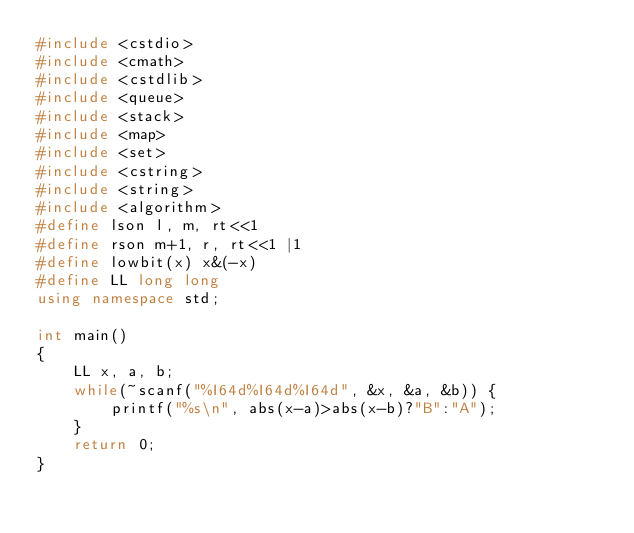<code> <loc_0><loc_0><loc_500><loc_500><_C++_>#include <cstdio>
#include <cmath>
#include <cstdlib>
#include <queue>
#include <stack>
#include <map>
#include <set>
#include <cstring>
#include <string>
#include <algorithm>
#define lson l, m, rt<<1
#define rson m+1, r, rt<<1 |1
#define lowbit(x) x&(-x)
#define LL long long
using namespace std;
 
int main()
{
    LL x, a, b;
    while(~scanf("%I64d%I64d%I64d", &x, &a, &b)) {
        printf("%s\n", abs(x-a)>abs(x-b)?"B":"A");
    }
    return 0;
}</code> 